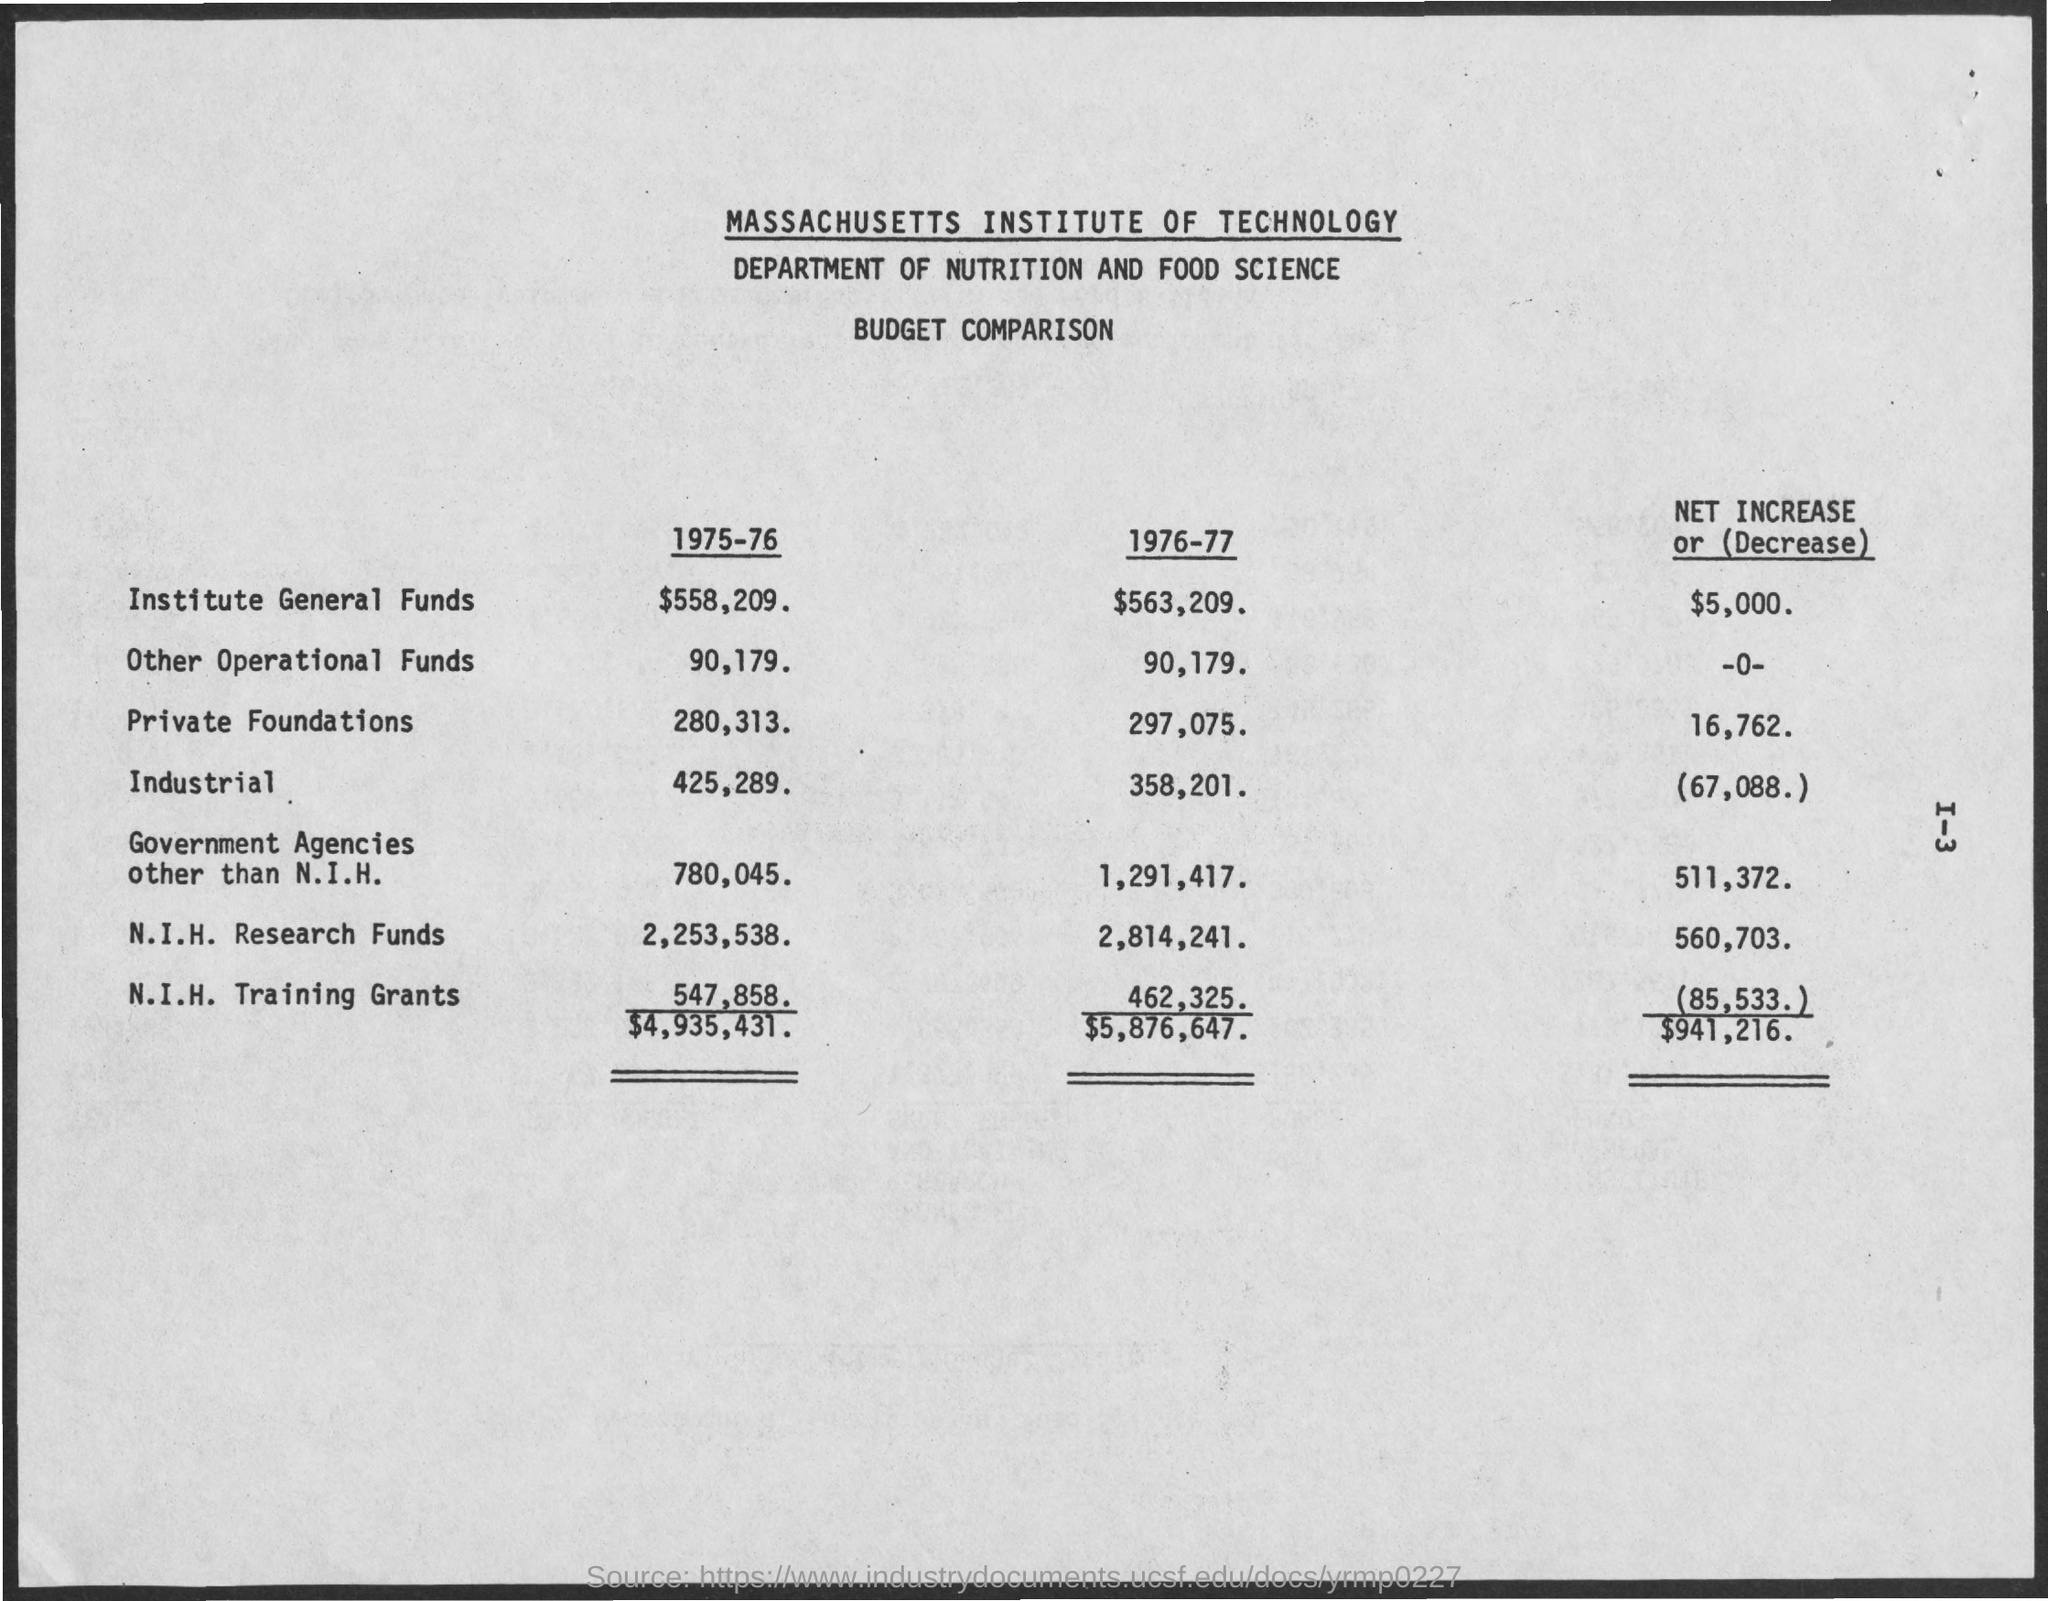How do the N.I.H. Research Funds for 1976-77 compare to the other categories? In comparison to the other funding categories for the year 1976-77, the N.I.H. Research Funds were substantial, totaling $2,814,241. This is notably higher than funds from private foundations and industrial sources, which were $297,075 and $358,201, respectively. Additionally, the N.I.H. Research Funds saw an increase from the prior year, unlike the Industrial funds, which decreased. 